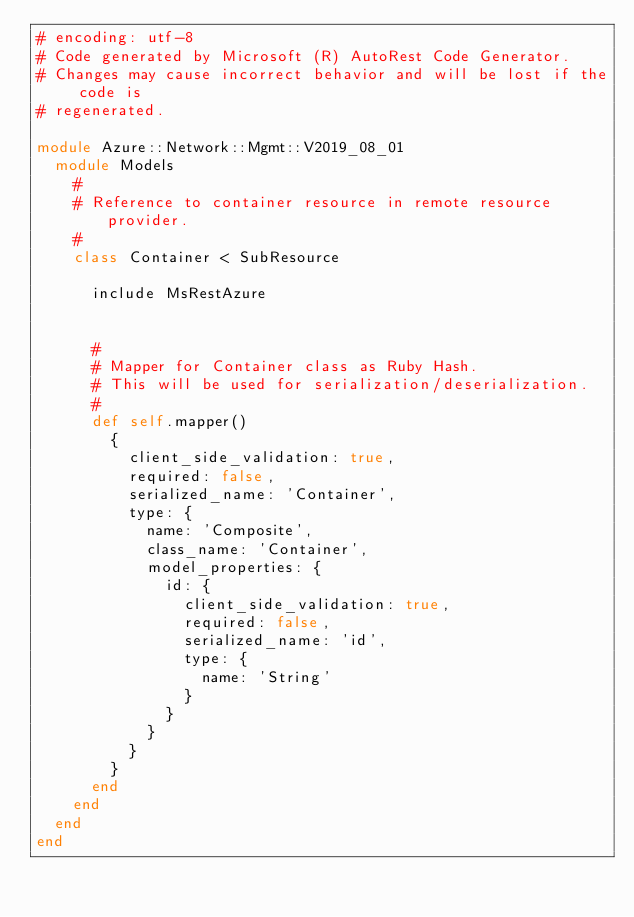<code> <loc_0><loc_0><loc_500><loc_500><_Ruby_># encoding: utf-8
# Code generated by Microsoft (R) AutoRest Code Generator.
# Changes may cause incorrect behavior and will be lost if the code is
# regenerated.

module Azure::Network::Mgmt::V2019_08_01
  module Models
    #
    # Reference to container resource in remote resource provider.
    #
    class Container < SubResource

      include MsRestAzure


      #
      # Mapper for Container class as Ruby Hash.
      # This will be used for serialization/deserialization.
      #
      def self.mapper()
        {
          client_side_validation: true,
          required: false,
          serialized_name: 'Container',
          type: {
            name: 'Composite',
            class_name: 'Container',
            model_properties: {
              id: {
                client_side_validation: true,
                required: false,
                serialized_name: 'id',
                type: {
                  name: 'String'
                }
              }
            }
          }
        }
      end
    end
  end
end
</code> 